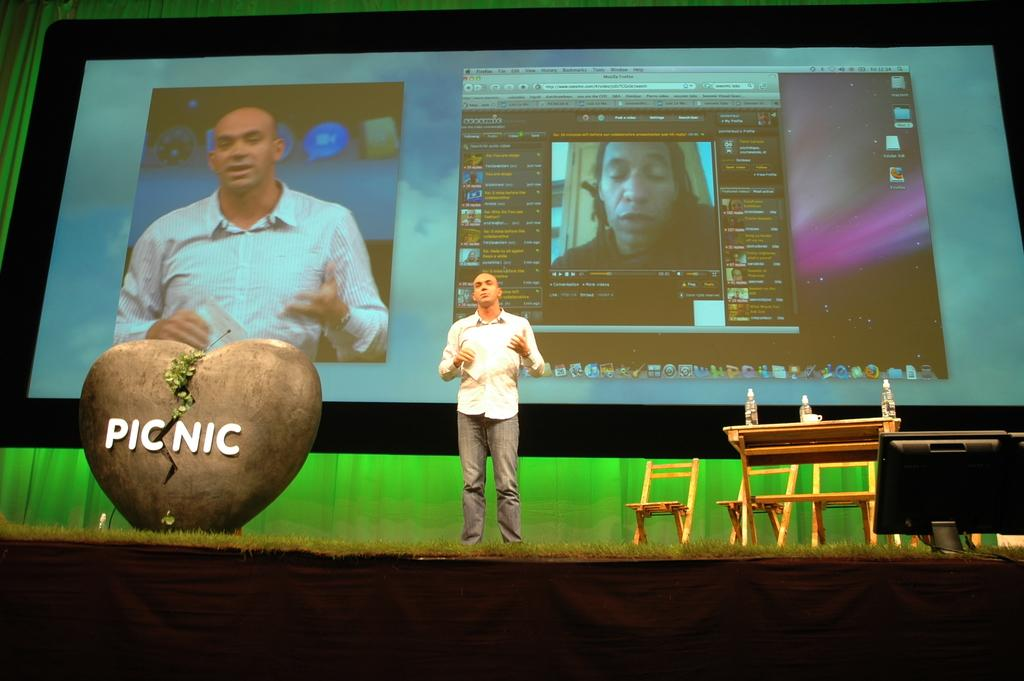What is the man in the image doing? The man is standing and speaking in the image. What furniture is present in the image? There is a table and chairs in the image. What electronic devices are visible in the image? There is a screen and a monitor in the image. How does the man shake the string in the image? There is no string present in the image, so the man cannot shake it. 